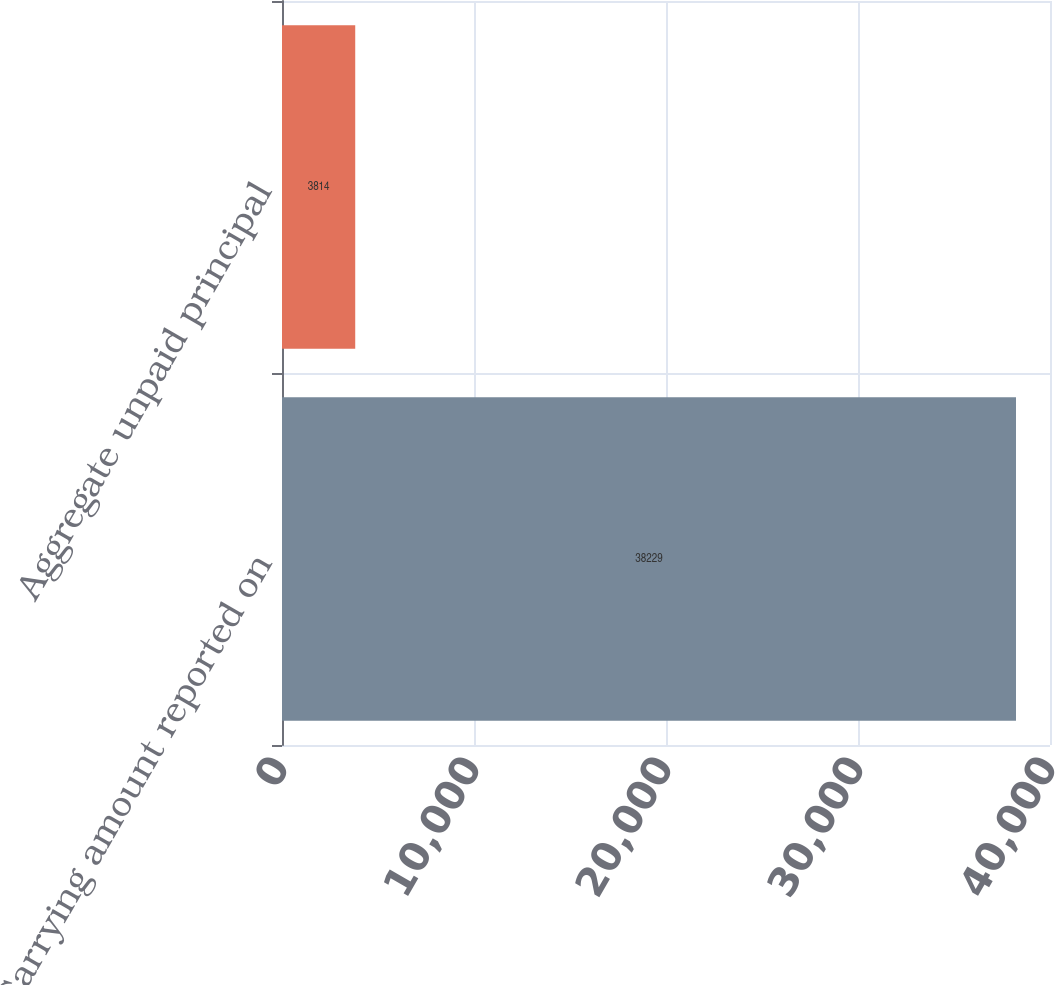Convert chart to OTSL. <chart><loc_0><loc_0><loc_500><loc_500><bar_chart><fcel>Carrying amount reported on<fcel>Aggregate unpaid principal<nl><fcel>38229<fcel>3814<nl></chart> 